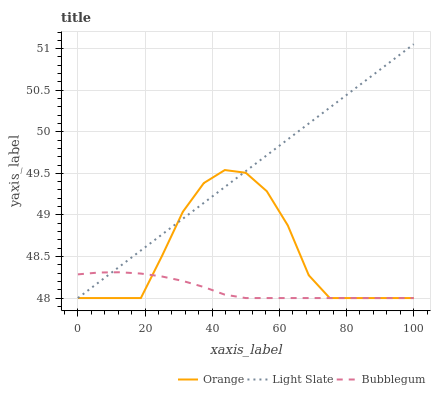Does Light Slate have the minimum area under the curve?
Answer yes or no. No. Does Bubblegum have the maximum area under the curve?
Answer yes or no. No. Is Bubblegum the smoothest?
Answer yes or no. No. Is Bubblegum the roughest?
Answer yes or no. No. Does Bubblegum have the highest value?
Answer yes or no. No. 